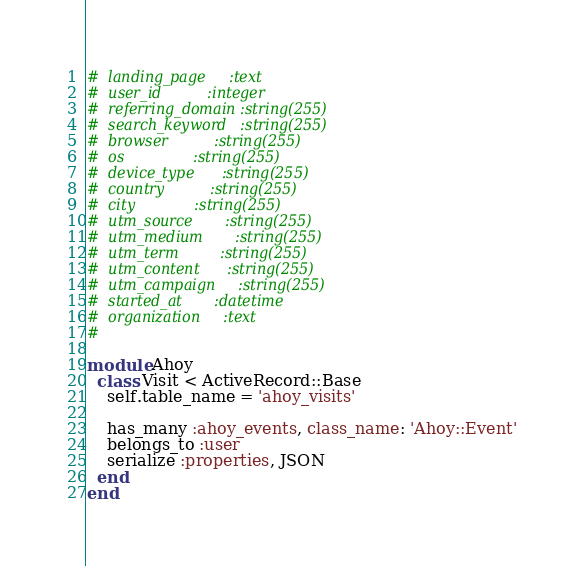<code> <loc_0><loc_0><loc_500><loc_500><_Ruby_>#  landing_page     :text
#  user_id          :integer
#  referring_domain :string(255)
#  search_keyword   :string(255)
#  browser          :string(255)
#  os               :string(255)
#  device_type      :string(255)
#  country          :string(255)
#  city             :string(255)
#  utm_source       :string(255)
#  utm_medium       :string(255)
#  utm_term         :string(255)
#  utm_content      :string(255)
#  utm_campaign     :string(255)
#  started_at       :datetime
#  organization     :text
#

module Ahoy
  class Visit < ActiveRecord::Base
    self.table_name = 'ahoy_visits'

    has_many :ahoy_events, class_name: 'Ahoy::Event'
    belongs_to :user
    serialize :properties, JSON
  end
end
</code> 